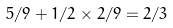Convert formula to latex. <formula><loc_0><loc_0><loc_500><loc_500>5 / 9 + 1 / 2 \times 2 / 9 = 2 / 3</formula> 